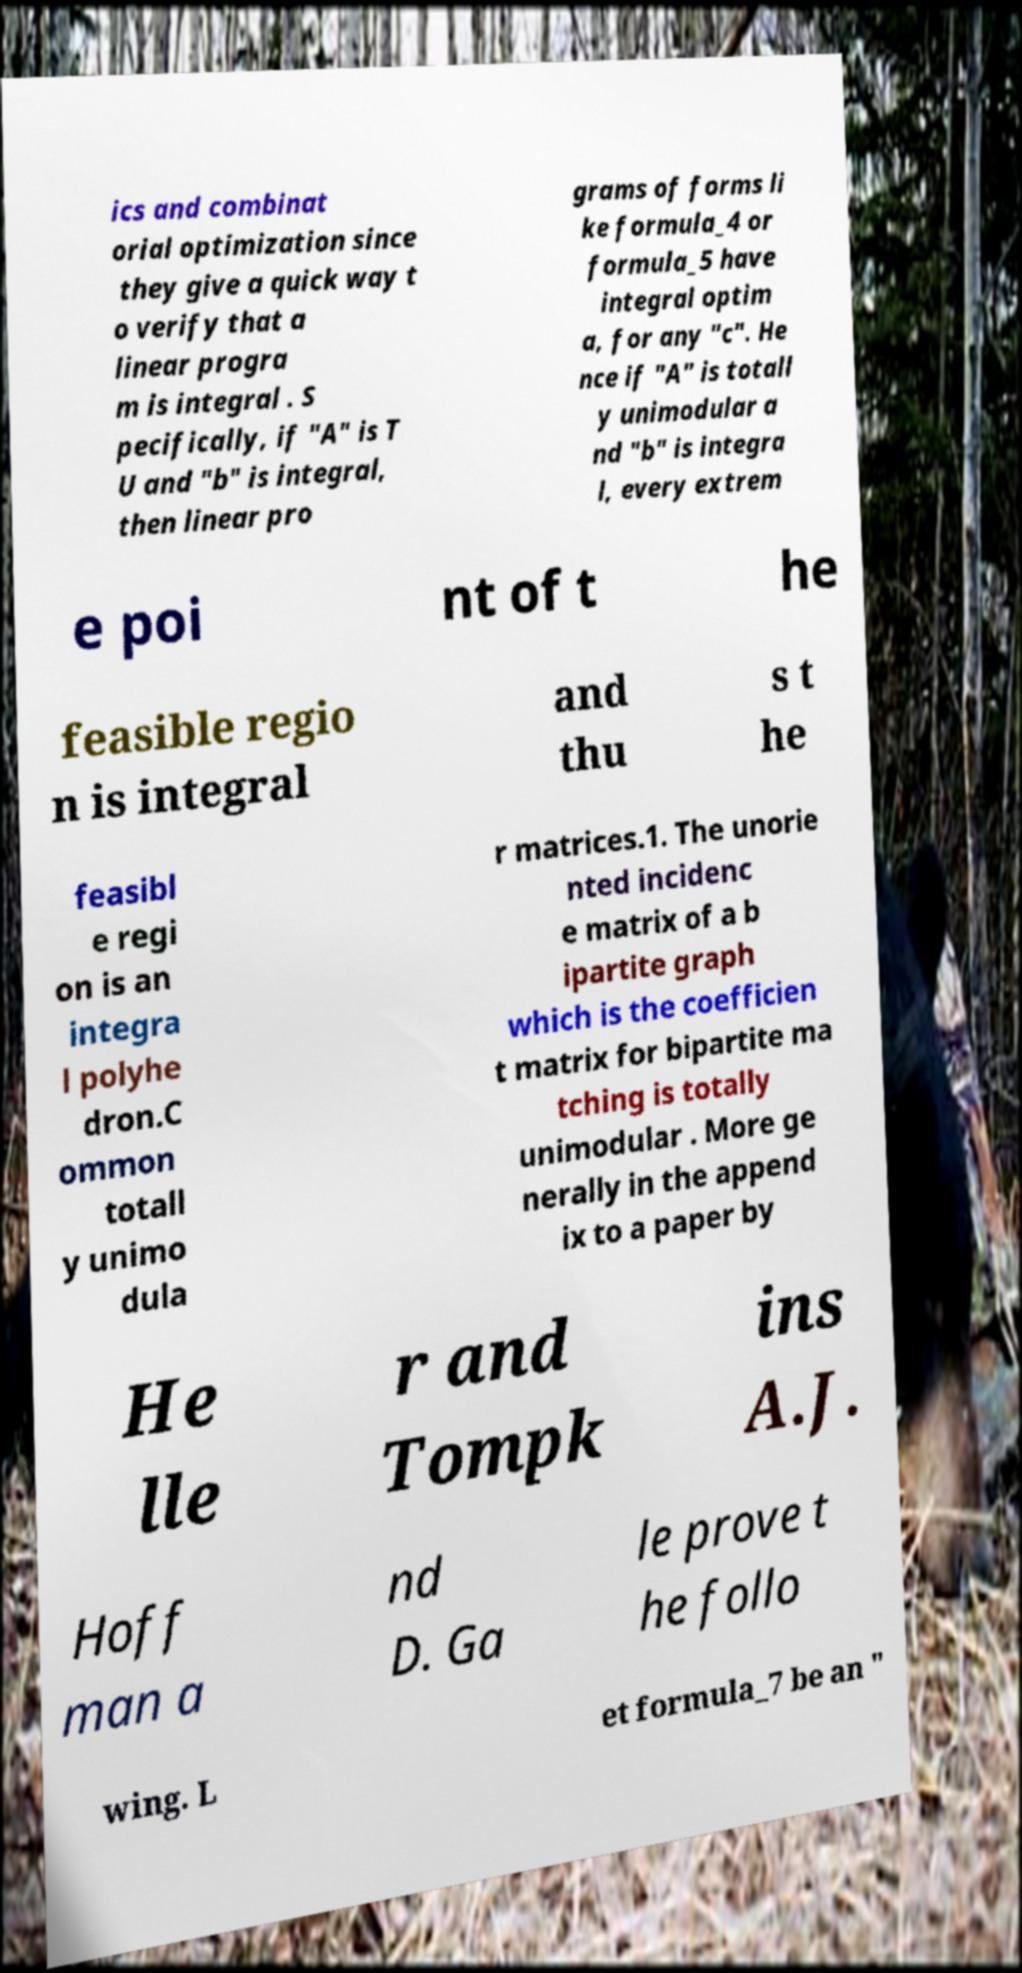Please read and relay the text visible in this image. What does it say? ics and combinat orial optimization since they give a quick way t o verify that a linear progra m is integral . S pecifically, if "A" is T U and "b" is integral, then linear pro grams of forms li ke formula_4 or formula_5 have integral optim a, for any "c". He nce if "A" is totall y unimodular a nd "b" is integra l, every extrem e poi nt of t he feasible regio n is integral and thu s t he feasibl e regi on is an integra l polyhe dron.C ommon totall y unimo dula r matrices.1. The unorie nted incidenc e matrix of a b ipartite graph which is the coefficien t matrix for bipartite ma tching is totally unimodular . More ge nerally in the append ix to a paper by He lle r and Tompk ins A.J. Hoff man a nd D. Ga le prove t he follo wing. L et formula_7 be an " 